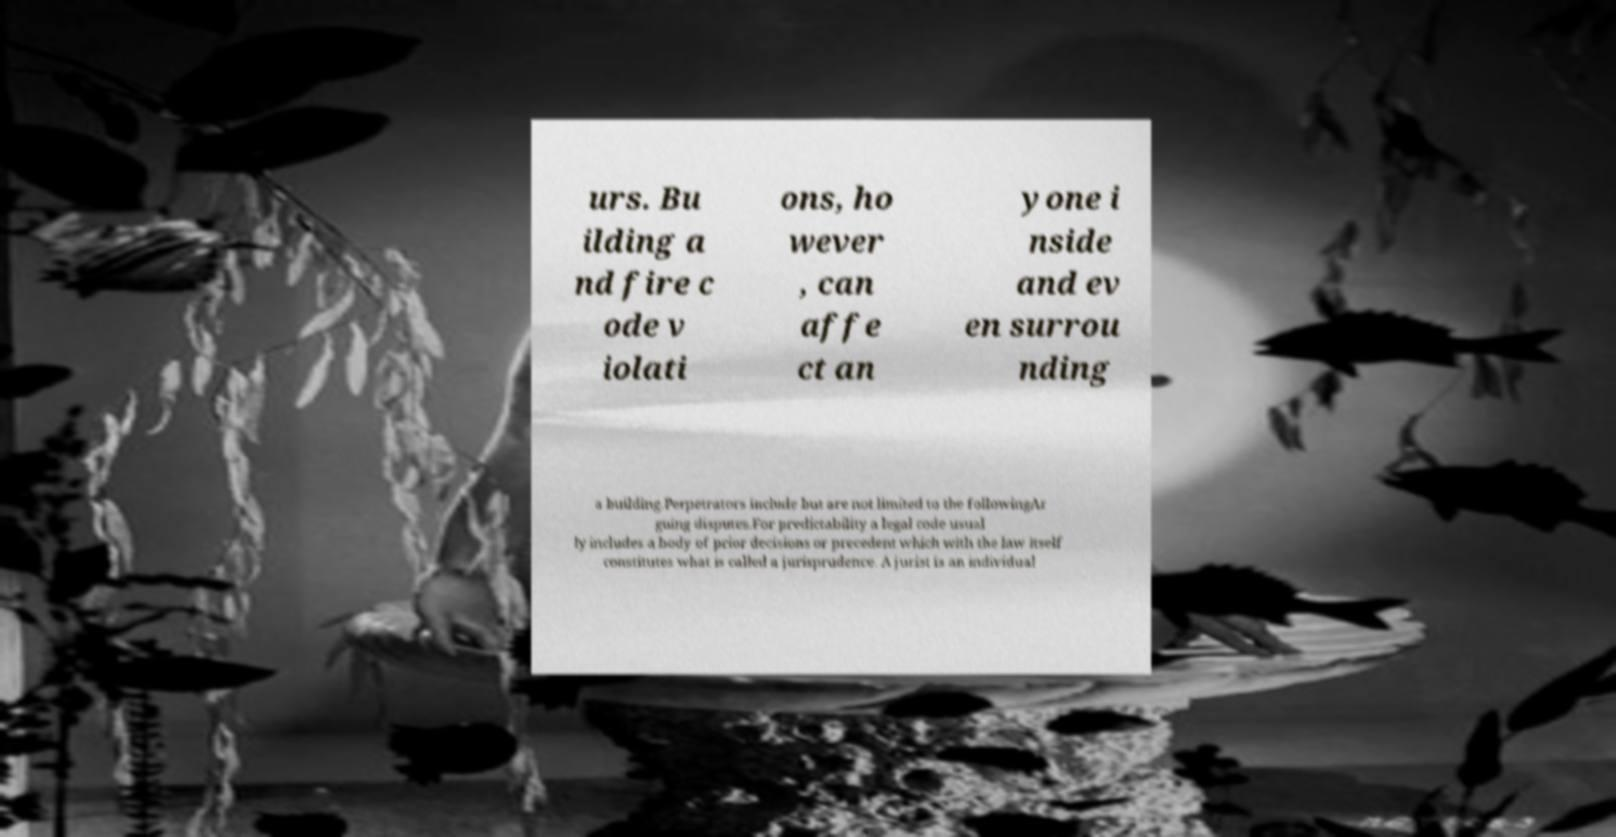For documentation purposes, I need the text within this image transcribed. Could you provide that? urs. Bu ilding a nd fire c ode v iolati ons, ho wever , can affe ct an yone i nside and ev en surrou nding a building.Perpetrators include but are not limited to the followingAr guing disputes.For predictability a legal code usual ly includes a body of prior decisions or precedent which with the law itself constitutes what is called a jurisprudence. A jurist is an individual 